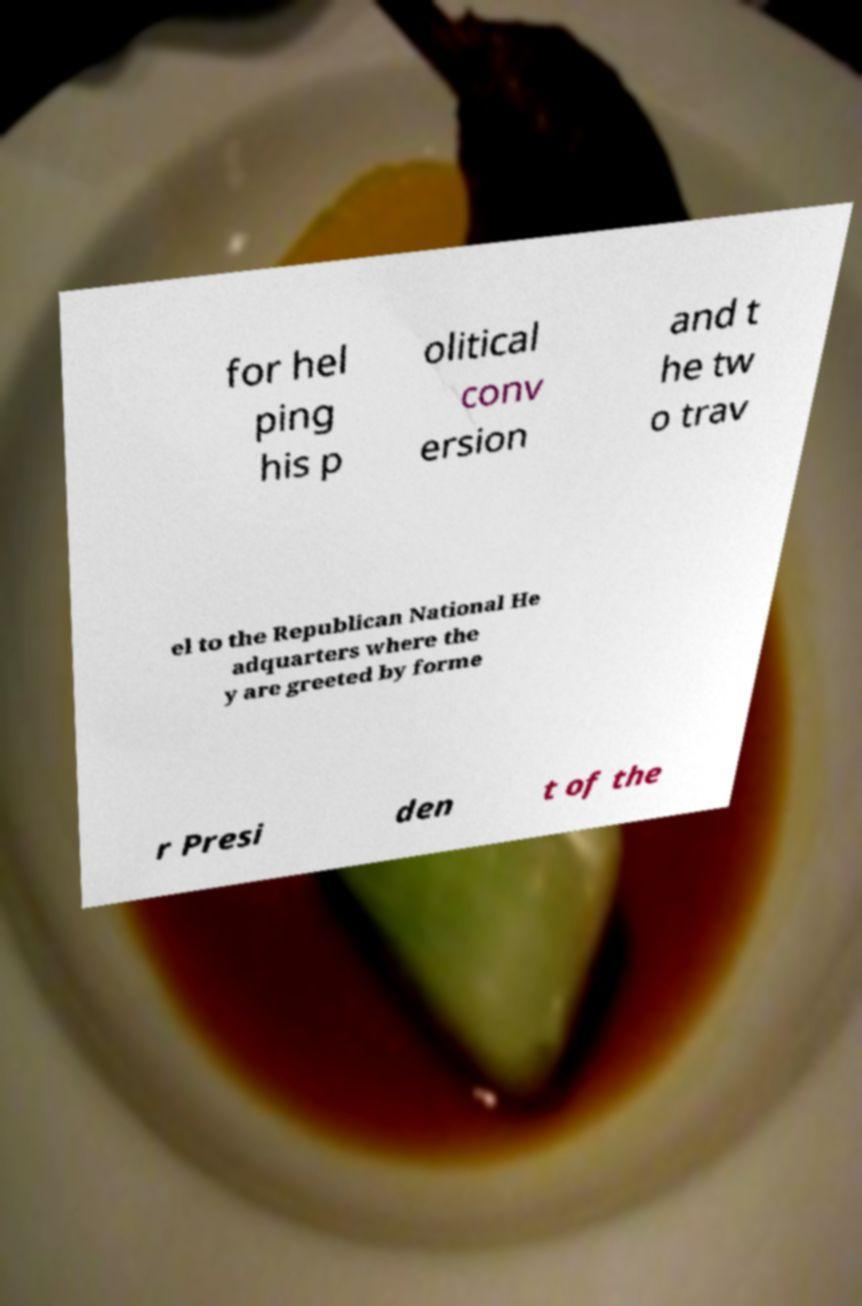What messages or text are displayed in this image? I need them in a readable, typed format. for hel ping his p olitical conv ersion and t he tw o trav el to the Republican National He adquarters where the y are greeted by forme r Presi den t of the 